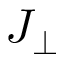Convert formula to latex. <formula><loc_0><loc_0><loc_500><loc_500>J _ { \perp }</formula> 